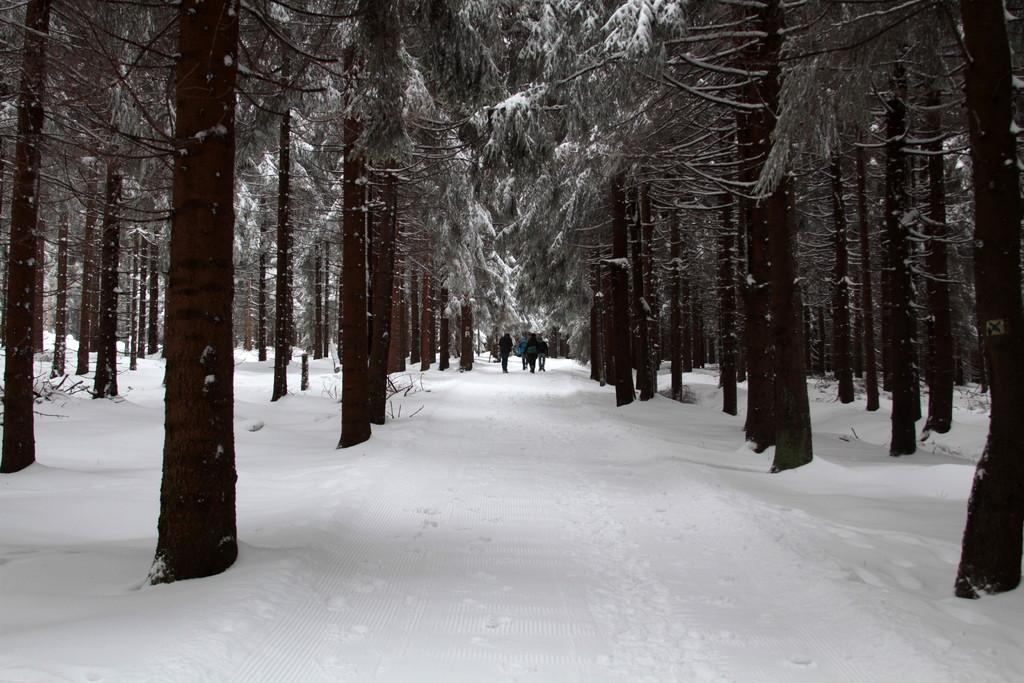What is covering the ground in the image? There is white colored snow on the ground. What can be seen in the background of the image? There are trees visible in the image. What are the people in the image doing? The people are standing on the snow. What type of drug can be seen in the hands of the people in the image? There is no drug present in the image; the people are standing on the snow. What seeds are the trees in the image using to grow? The trees in the image do not have seeds visible, and trees do not use seeds to grow in the way the question suggests. 